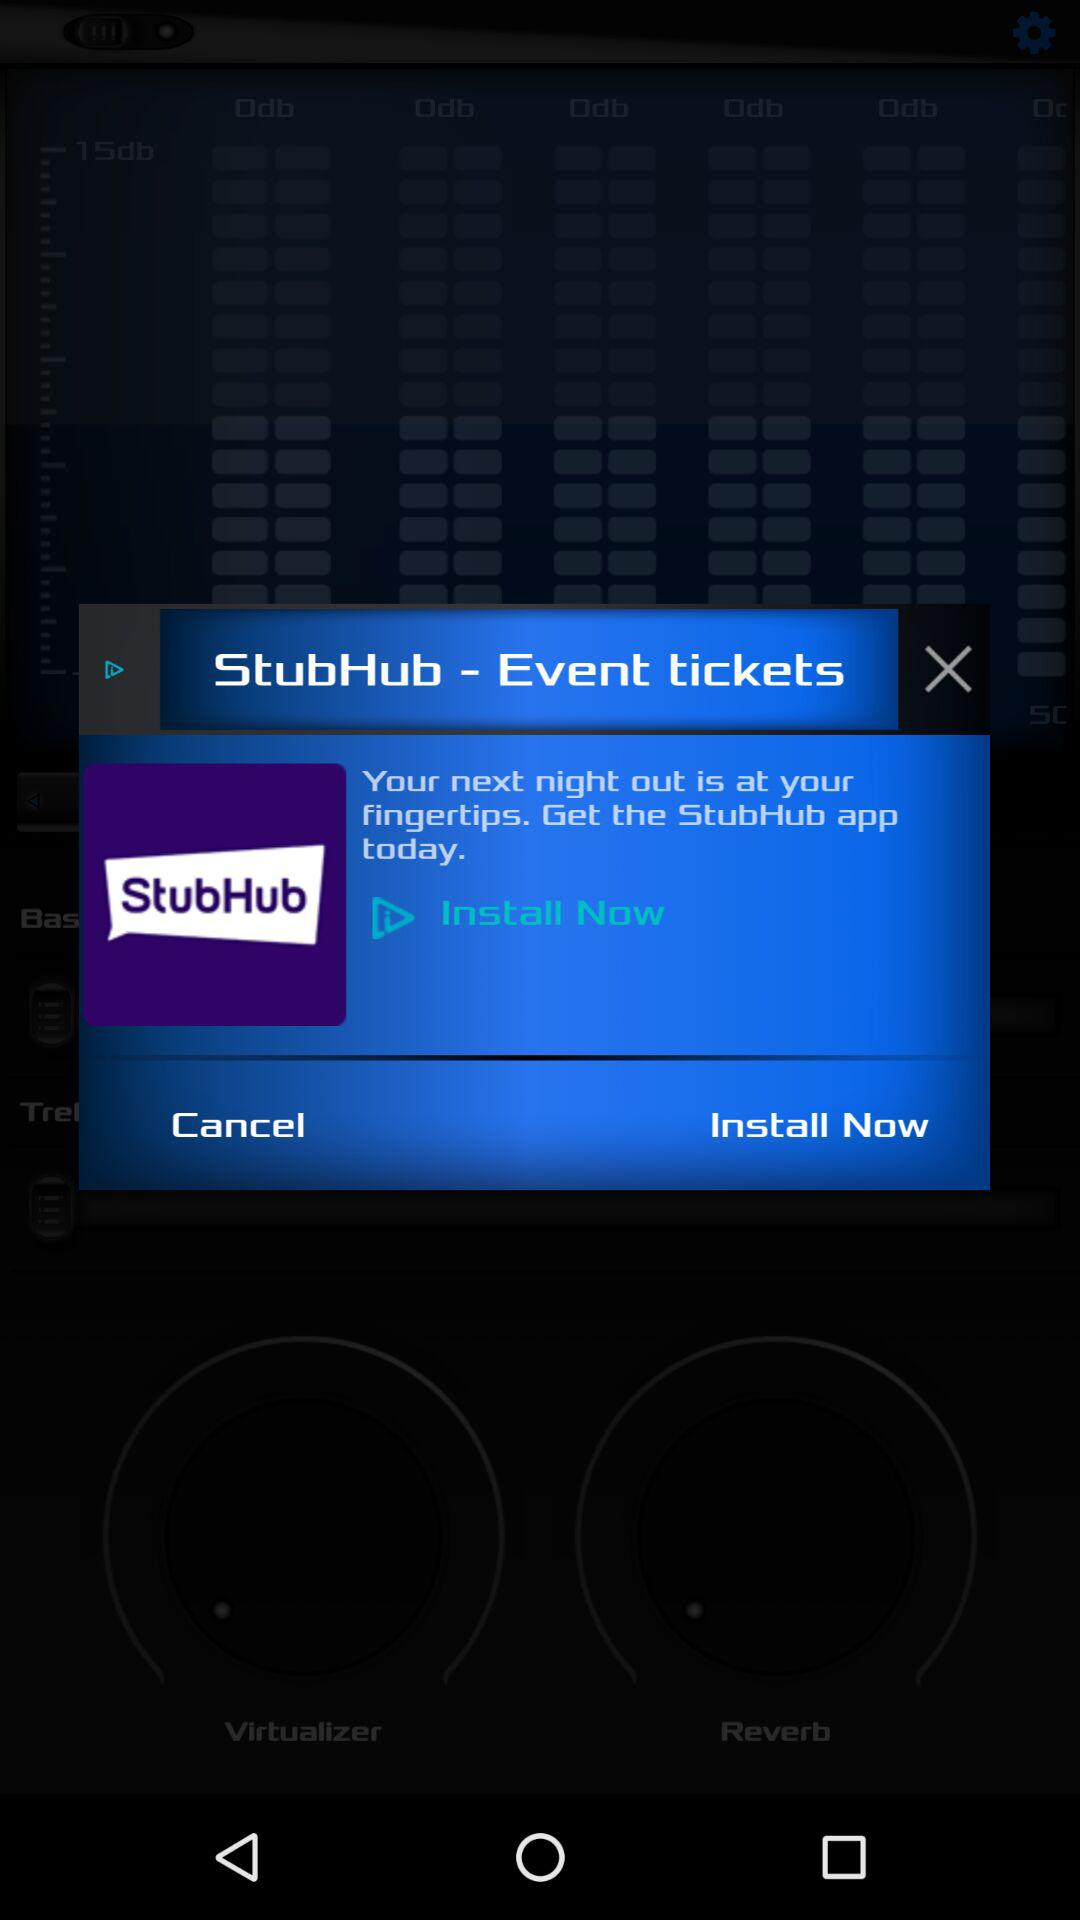What is the name of the application? The name of the application is "StubHub - Event tickets". 